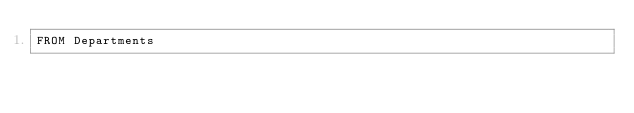<code> <loc_0><loc_0><loc_500><loc_500><_SQL_>FROM Departments</code> 